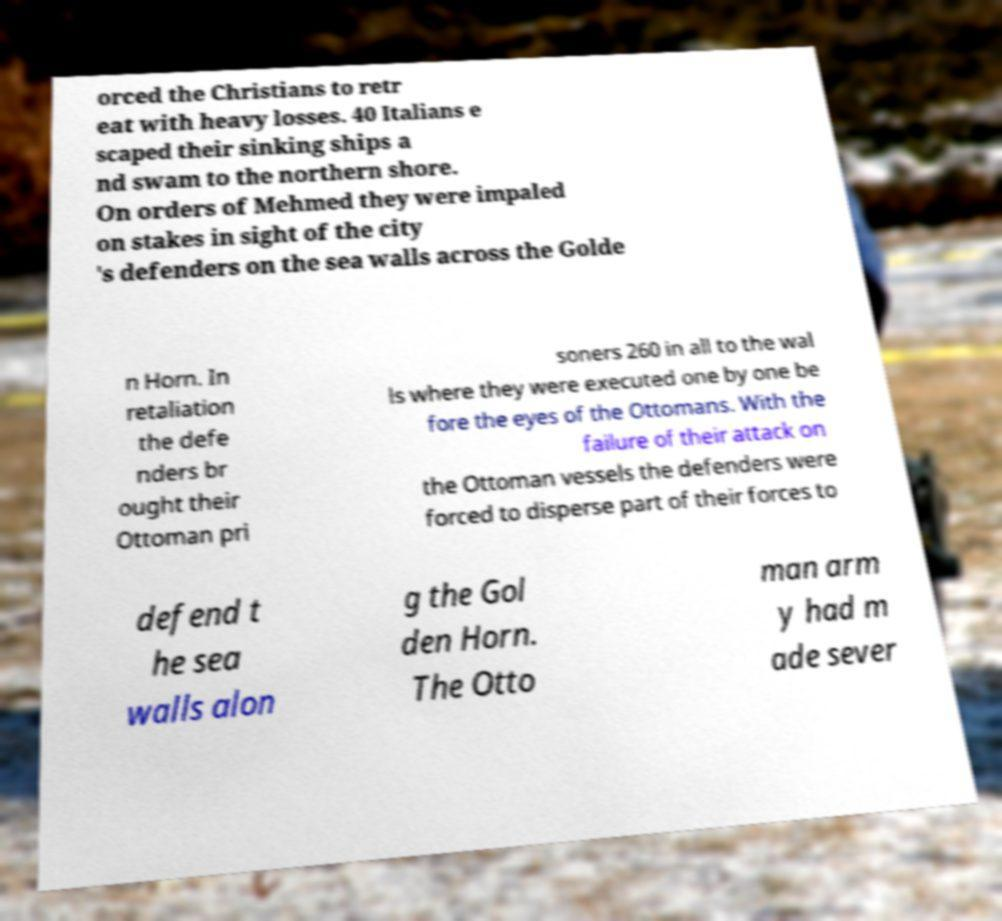For documentation purposes, I need the text within this image transcribed. Could you provide that? orced the Christians to retr eat with heavy losses. 40 Italians e scaped their sinking ships a nd swam to the northern shore. On orders of Mehmed they were impaled on stakes in sight of the city 's defenders on the sea walls across the Golde n Horn. In retaliation the defe nders br ought their Ottoman pri soners 260 in all to the wal ls where they were executed one by one be fore the eyes of the Ottomans. With the failure of their attack on the Ottoman vessels the defenders were forced to disperse part of their forces to defend t he sea walls alon g the Gol den Horn. The Otto man arm y had m ade sever 